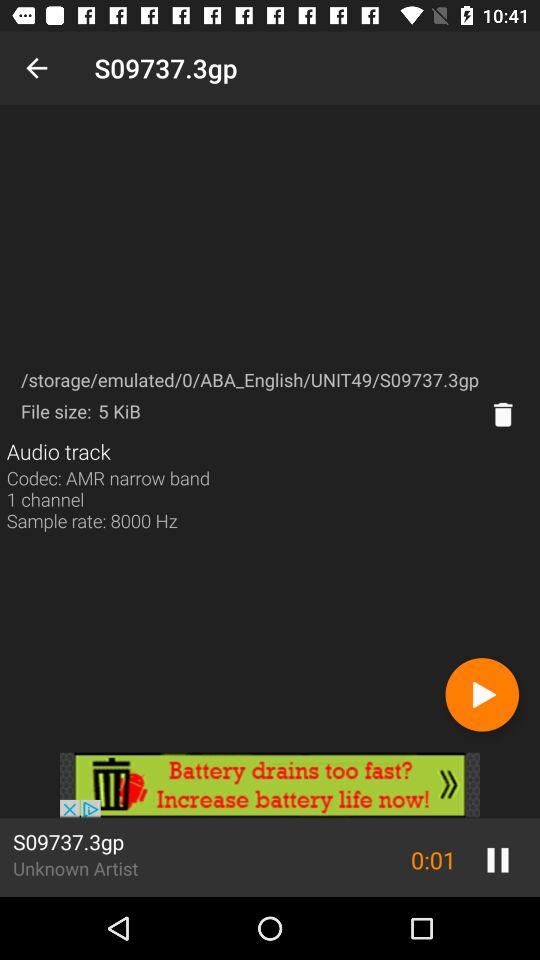How many more audio tracks are there than channels?
Answer the question using a single word or phrase. 0 